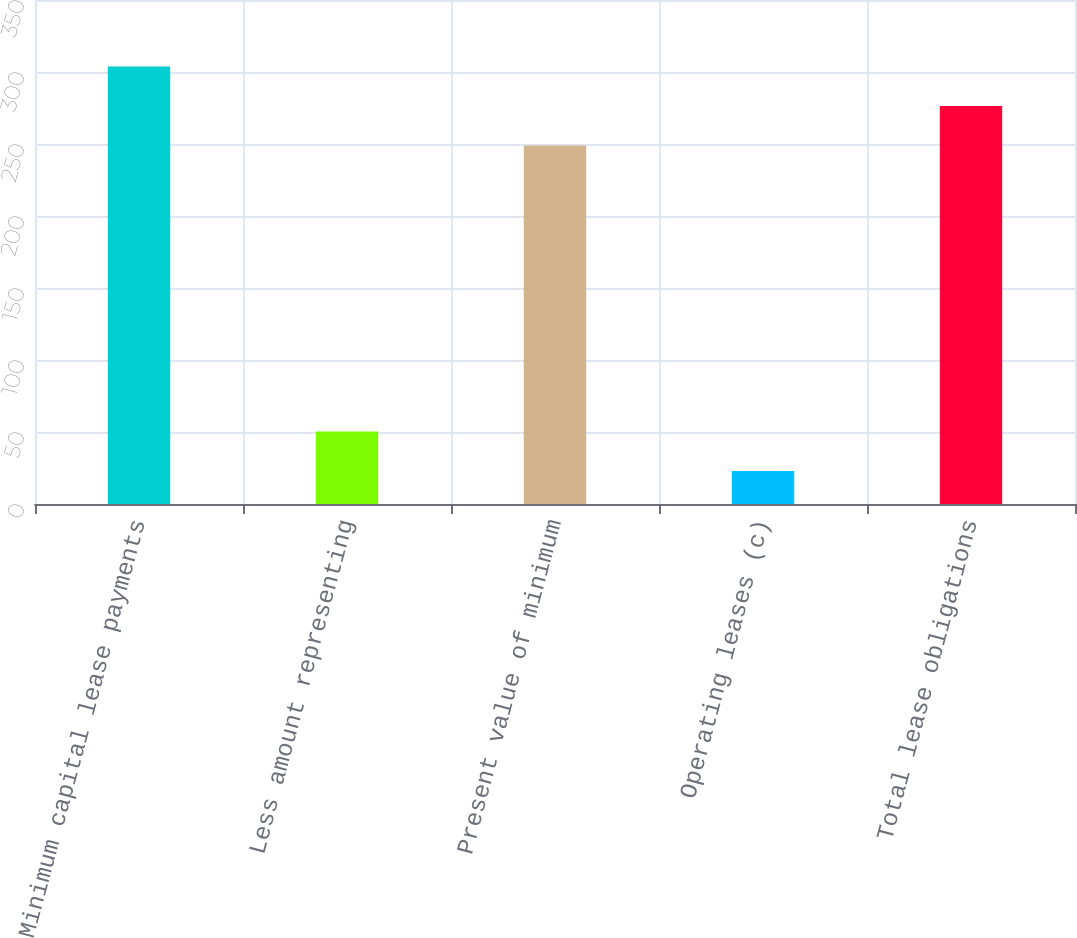Convert chart to OTSL. <chart><loc_0><loc_0><loc_500><loc_500><bar_chart><fcel>Minimum capital lease payments<fcel>Less amount representing<fcel>Present value of minimum<fcel>Operating leases (c)<fcel>Total lease obligations<nl><fcel>303.8<fcel>50.4<fcel>249<fcel>23<fcel>276.4<nl></chart> 